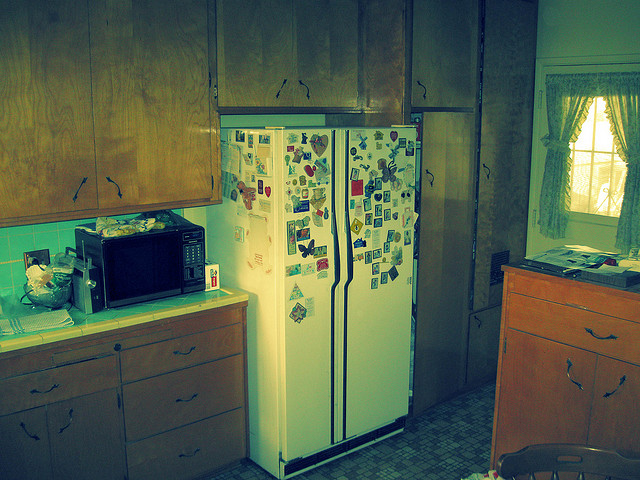<image>What page from the newspaper has been tacked to the wall? It's ambiguous which page from the newspaper has been tacked to the wall. It might be the front page, comics, sports or wedding announcement. What page from the newspaper has been tacked to the wall? There is no page from the newspaper tacked to the wall. 